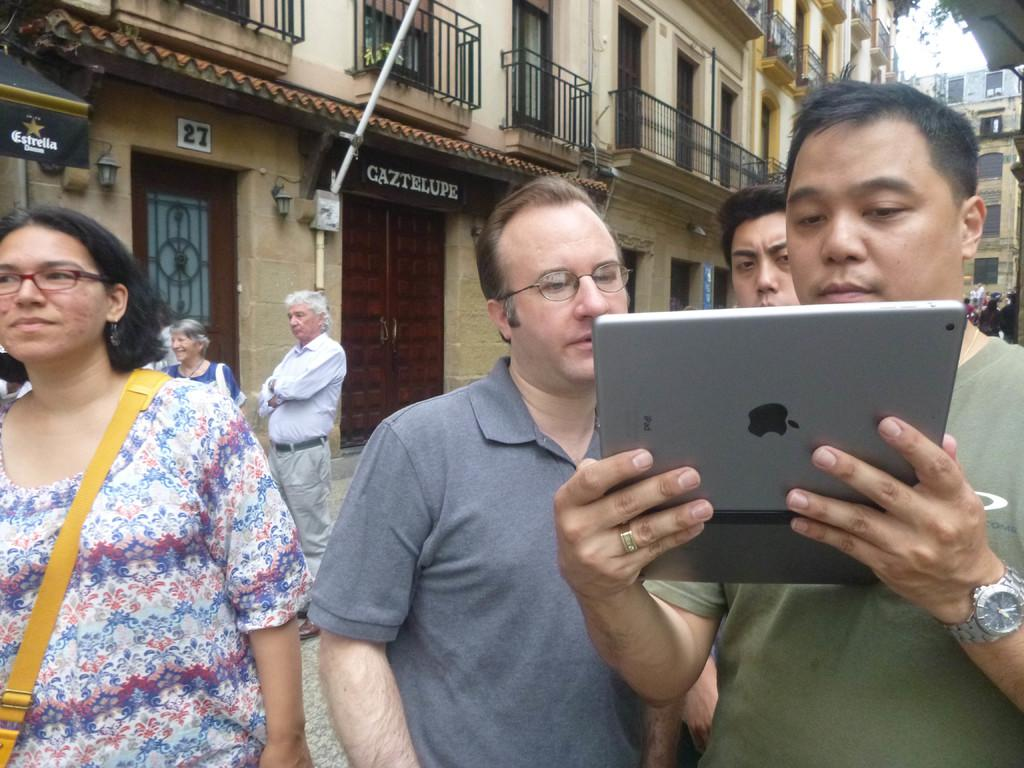How many persons are in the image? There are persons in the image, but the exact number is not specified. What is one person holding in the image? One person is holding an Apple device. What can be seen in the background of the image? There are buildings, doors, and boards in the background of the image. What is visible part of the natural environment is present in the image? The sky is visible in the background of the image. What type of idea is being discussed by the persons in the image? There is no information about any ideas being discussed in the image. Can you describe the hall where the persons are standing in the image? There is no mention of a hall in the image; it only shows persons, an Apple device, and the background elements. 